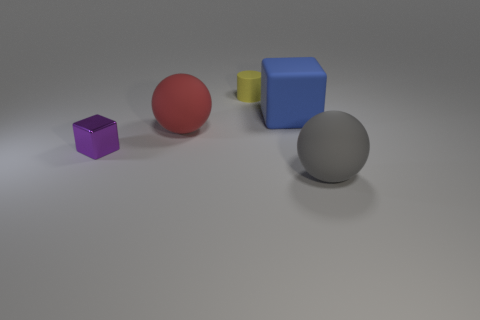Add 5 tiny brown matte balls. How many objects exist? 10 Subtract all spheres. How many objects are left? 3 Subtract all purple cubes. How many cubes are left? 1 Subtract 1 balls. How many balls are left? 1 Add 1 small purple cylinders. How many small purple cylinders exist? 1 Subtract 0 yellow blocks. How many objects are left? 5 Subtract all purple cubes. Subtract all purple cylinders. How many cubes are left? 1 Subtract all green balls. How many blue blocks are left? 1 Subtract all large blue rubber objects. Subtract all big matte spheres. How many objects are left? 2 Add 4 tiny objects. How many tiny objects are left? 6 